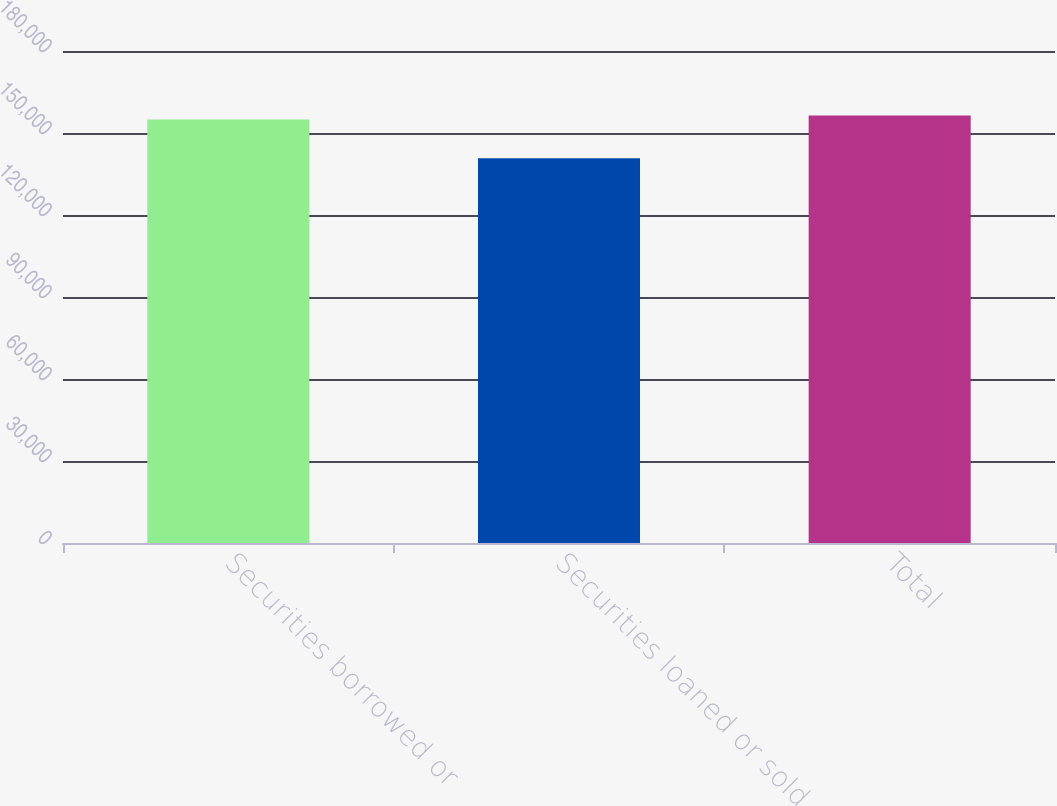Convert chart to OTSL. <chart><loc_0><loc_0><loc_500><loc_500><bar_chart><fcel>Securities borrowed or<fcel>Securities loaned or sold<fcel>Total<nl><fcel>154974<fcel>140774<fcel>156419<nl></chart> 